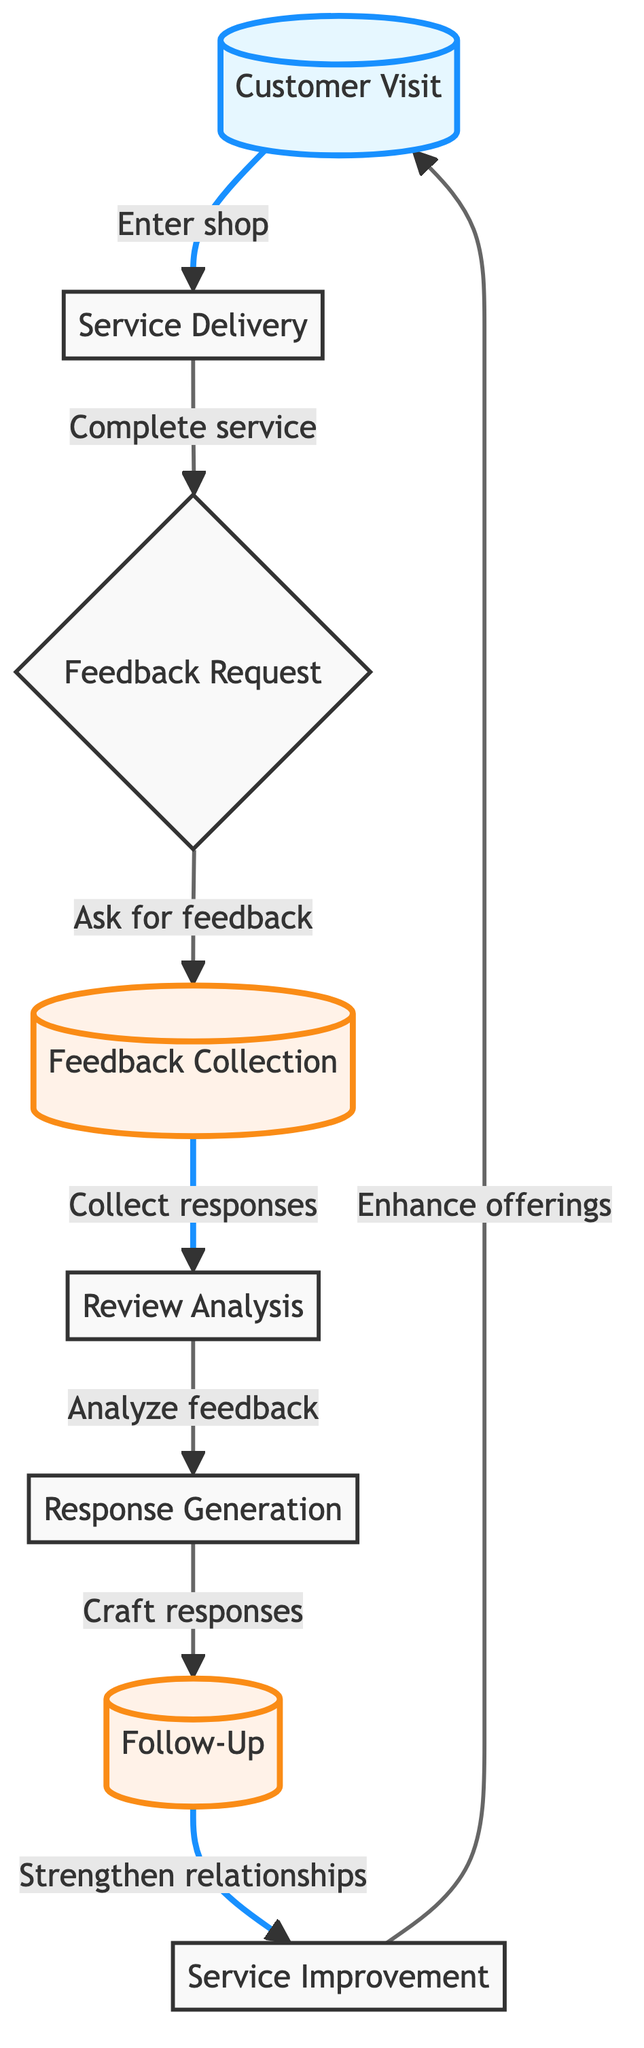What is the first step in the flow chart? The first step in the flow chart is labeled "Customer Visit". This is identified as the starting point of the process where the customer enters the tire shop.
Answer: Customer Visit How many total steps are there in the diagram? By counting the nodes listed in the diagram, we find there are eight distinct steps that make up the entire customer feedback collection and response flow.
Answer: 8 What action follows "Service Delivery"? In the flow chart, after "Service Delivery", the next action is "Feedback Request". This indicates that feedback is requested from the customer right after the service is completed.
Answer: Feedback Request Which step involves personal responses to feedback? The step that involves crafting personal responses to feedback is labeled "Response Generation". This step is crucial for addressing customer concerns or expressing gratitude.
Answer: Response Generation What step immediately precedes "Service Improvement"? The step that immediately comes before "Service Improvement" is "Follow-Up". This connection shows that following up with customers is essential for gaining insights that help improve services.
Answer: Follow-Up What is the purpose of "Review Analysis"? The purpose of "Review Analysis" is to assess customer satisfaction based on the collected feedback. This analysis helps the tire shop owner understand how well they have met customer expectations.
Answer: Assess customer satisfaction How does "Feedback Collection" influence the flow? "Feedback Collection" serves as a critical transition point in the flow, connecting the feedback request made to customers and the subsequent analysis of the feedback provided. It maintains the process of gathering customer insights.
Answer: Transition point Which step strengthens relationships with customers? The step that strengthens relationships with customers is "Follow-Up". This indicates the intention to ensure customers are satisfied and to nurture long-term relationships.
Answer: Follow-Up What happens after 'Feedback Request'? After "Feedback Request", the chart states the action is "Feedback Collection". This means once feedback is requested, the next action is to actively gather that feedback from the customer.
Answer: Feedback Collection 